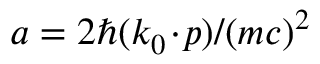<formula> <loc_0><loc_0><loc_500><loc_500>a = 2 \hbar { ( } k _ { 0 } \, \cdot \, p ) / ( m c ) ^ { 2 }</formula> 